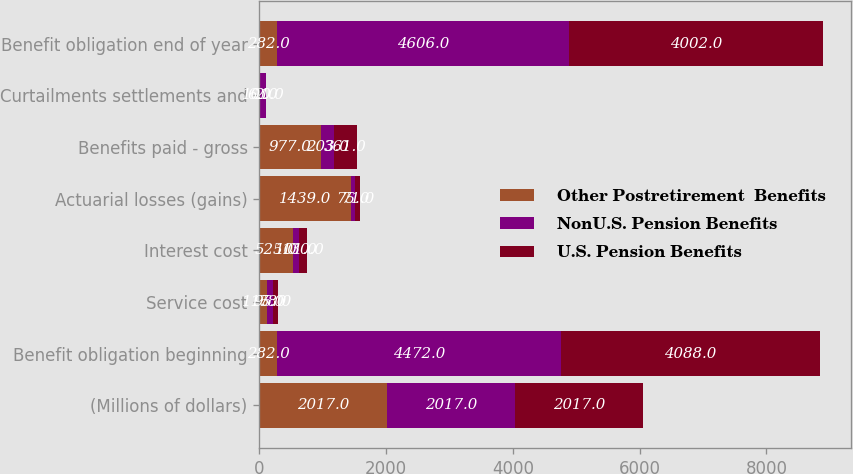Convert chart to OTSL. <chart><loc_0><loc_0><loc_500><loc_500><stacked_bar_chart><ecel><fcel>(Millions of dollars)<fcel>Benefit obligation beginning<fcel>Service cost<fcel>Interest cost<fcel>Actuarial losses (gains)<fcel>Benefits paid - gross<fcel>Curtailments settlements and<fcel>Benefit obligation end of year<nl><fcel>Other Postretirement  Benefits<fcel>2017<fcel>282<fcel>115<fcel>525<fcel>1439<fcel>977<fcel>6<fcel>282<nl><fcel>NonU.S. Pension Benefits<fcel>2017<fcel>4472<fcel>95<fcel>101<fcel>75<fcel>203<fcel>101<fcel>4606<nl><fcel>U.S. Pension Benefits<fcel>2017<fcel>4088<fcel>78<fcel>130<fcel>71<fcel>361<fcel>2<fcel>4002<nl></chart> 